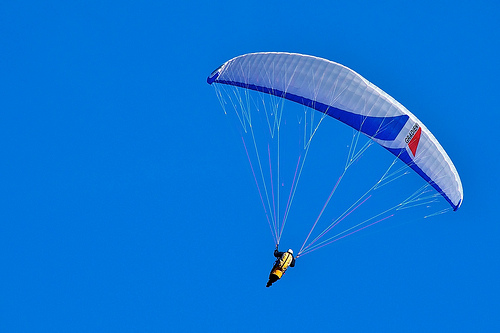In which part of the image is the parachute, the top or the bottom? The parachute is situated in the bottom part of the image. 